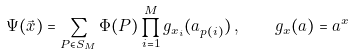Convert formula to latex. <formula><loc_0><loc_0><loc_500><loc_500>\Psi ( \vec { x } ) = \sum _ { P \in S _ { M } } \Phi ( P ) \prod ^ { M } _ { i = 1 } g _ { x _ { i } } ( a _ { p ( i ) } ) \, , \quad g _ { x } ( a ) = a ^ { x }</formula> 